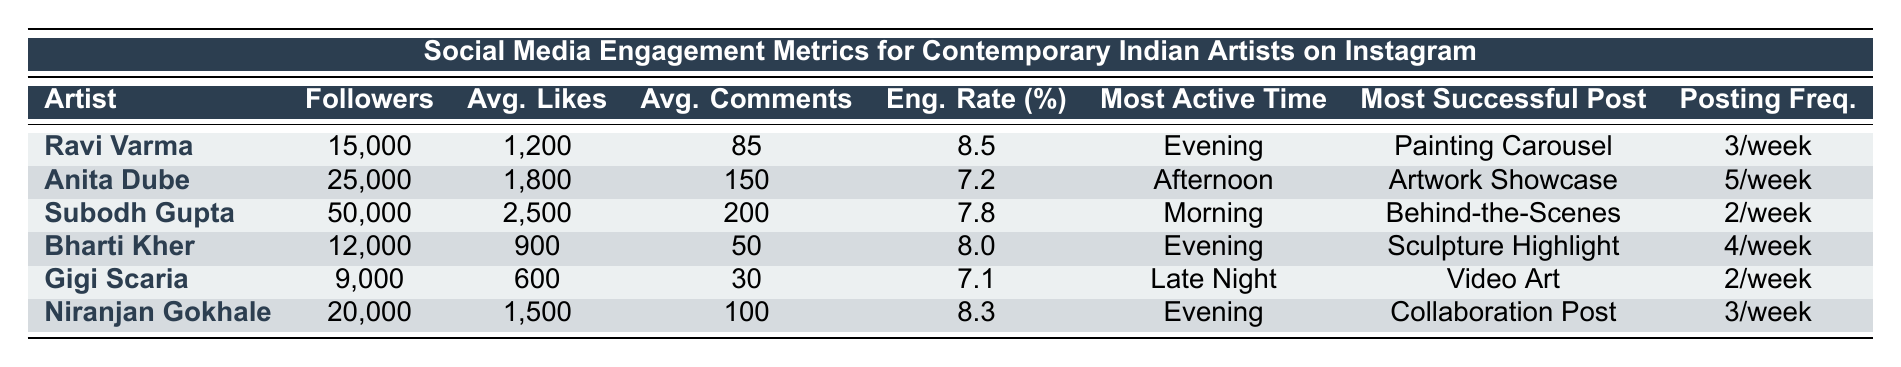What is the average engagement rate of the artists listed? We add the engagement rates of all the artists: (8.5 + 7.2 + 7.8 + 8.0 + 7.1 + 8.3) = 48.9. There are 6 artists, so we divide by 6 to find the average: 48.9 / 6 = 8.15
Answer: 8.15 Which artist has the highest average likes per post? By comparing the average likes for each artist, Subodh Gupta has the highest at 2500 likes per post.
Answer: Subodh Gupta Is Bharti Kher's engagement rate higher than that of Anita Dube? Bharti Kher has an engagement rate of 8.0, while Anita Dube has 7.2. Since 8.0 is greater than 7.2, the statement is true.
Answer: Yes What is the total number of followers for all the artists combined? Summing up the followers: 15000 + 25000 + 50000 + 12000 + 9000 + 20000 = 130000.
Answer: 130000 How many artists have a posting frequency of 2 times a week? By examining the posting frequency, we find that Subodh Gupta and Gigi Scaria both post 2 times a week, totaling 2 artists.
Answer: 2 During which time do most artists tend to be most active? By reviewing the most active times, we see that "Evening" appears for Ravi Varma, Bharti Kher, and Niranjan Gokhale. Since this is the most frequent time listed, it is the most common.
Answer: Evening Which artist is most successful with painting carousels? The table indicates that Ravi Varma's most successful post type is "Painting Carousel," suggesting he excels in this format.
Answer: Ravi Varma What is the difference in average comments per post between Gigi Scaria and Niranjan Gokhale? Gigi Scaria receives an average of 30 comments, while Niranjan Gokhale gets 100. The difference is 100 - 30 = 70.
Answer: 70 Which artist engages with followers more, based on engagement rate? Analyzing the engagement rates, Ravi Varma at 8.5% has the highest engagement rate compared to all others, suggesting he engages most effectively.
Answer: Ravi Varma What is the average number of likes across all artists who showcase their artwork? The artists who showcase their artwork are Anita Dube and Bharti Kher. Their average likes are (1800 + 900) / 2 = 1350.
Answer: 1350 